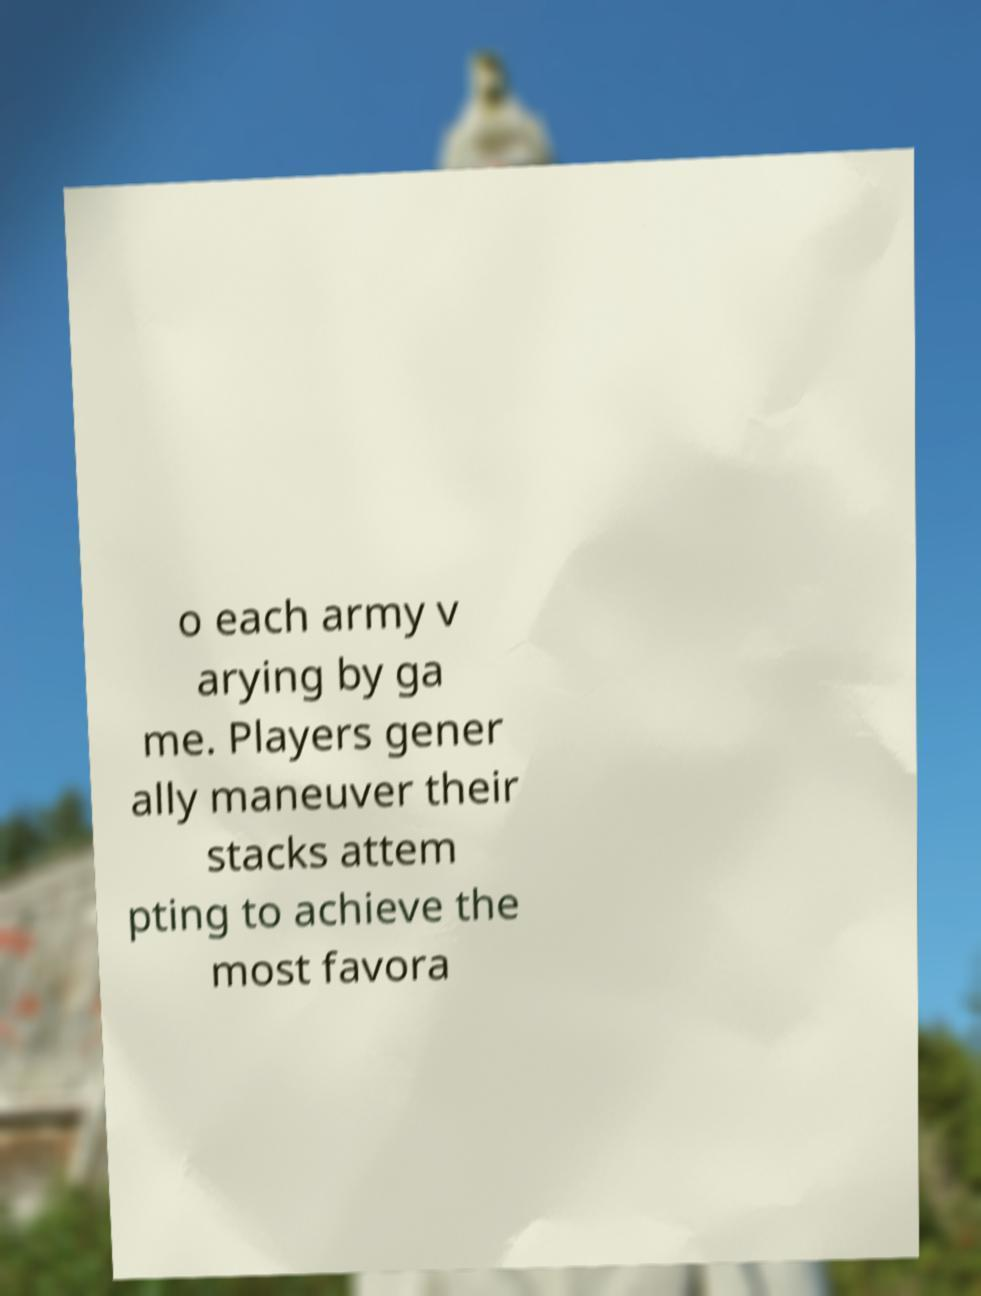For documentation purposes, I need the text within this image transcribed. Could you provide that? o each army v arying by ga me. Players gener ally maneuver their stacks attem pting to achieve the most favora 